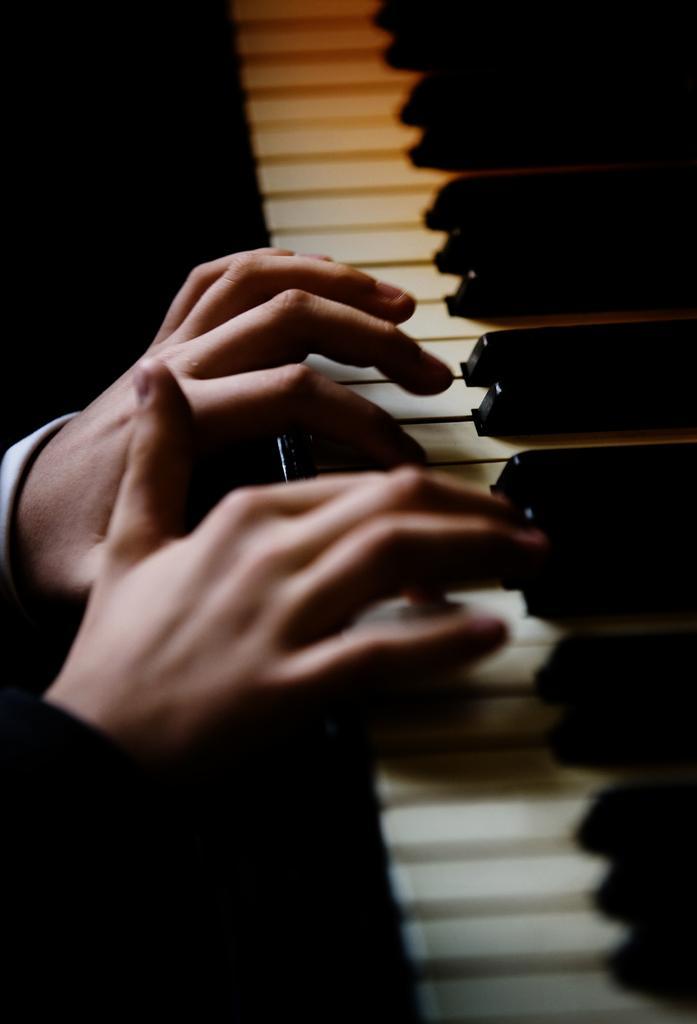In one or two sentences, can you explain what this image depicts? A person is playing piano. 